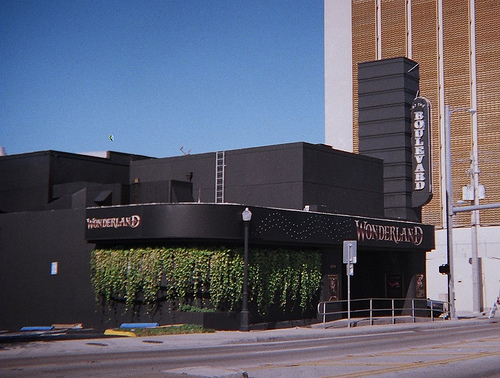<image>
Can you confirm if the street sign is on the building? No. The street sign is not positioned on the building. They may be near each other, but the street sign is not supported by or resting on top of the building. 